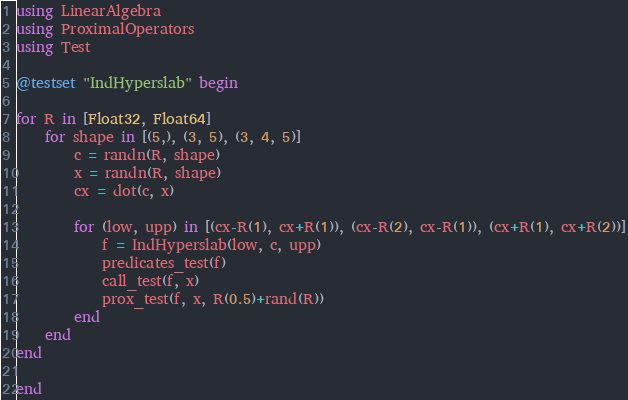<code> <loc_0><loc_0><loc_500><loc_500><_Julia_>using LinearAlgebra
using ProximalOperators
using Test

@testset "IndHyperslab" begin

for R in [Float32, Float64]
    for shape in [(5,), (3, 5), (3, 4, 5)]
        c = randn(R, shape)
        x = randn(R, shape)
        cx = dot(c, x)

        for (low, upp) in [(cx-R(1), cx+R(1)), (cx-R(2), cx-R(1)), (cx+R(1), cx+R(2))]
            f = IndHyperslab(low, c, upp)
            predicates_test(f)
            call_test(f, x)
            prox_test(f, x, R(0.5)+rand(R))
        end
    end
end

end
</code> 